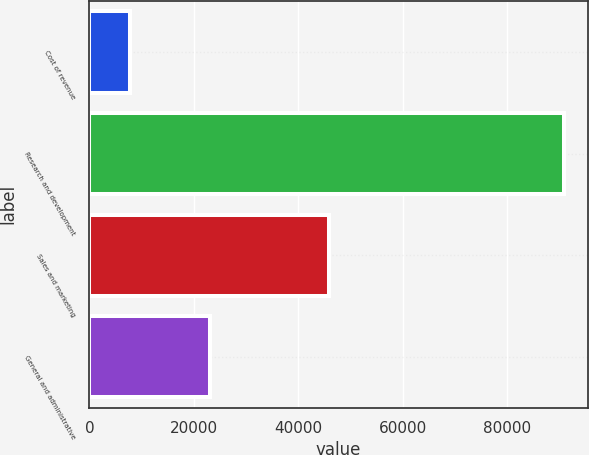<chart> <loc_0><loc_0><loc_500><loc_500><bar_chart><fcel>Cost of revenue<fcel>Research and development<fcel>Sales and marketing<fcel>General and administrative<nl><fcel>7858<fcel>90916<fcel>45856<fcel>23065<nl></chart> 